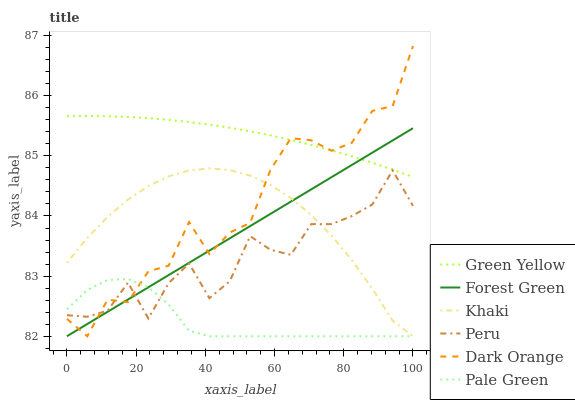Does Pale Green have the minimum area under the curve?
Answer yes or no. Yes. Does Green Yellow have the maximum area under the curve?
Answer yes or no. Yes. Does Khaki have the minimum area under the curve?
Answer yes or no. No. Does Khaki have the maximum area under the curve?
Answer yes or no. No. Is Forest Green the smoothest?
Answer yes or no. Yes. Is Dark Orange the roughest?
Answer yes or no. Yes. Is Khaki the smoothest?
Answer yes or no. No. Is Khaki the roughest?
Answer yes or no. No. Does Peru have the lowest value?
Answer yes or no. No. Does Khaki have the highest value?
Answer yes or no. No. Is Khaki less than Green Yellow?
Answer yes or no. Yes. Is Green Yellow greater than Peru?
Answer yes or no. Yes. Does Khaki intersect Green Yellow?
Answer yes or no. No. 